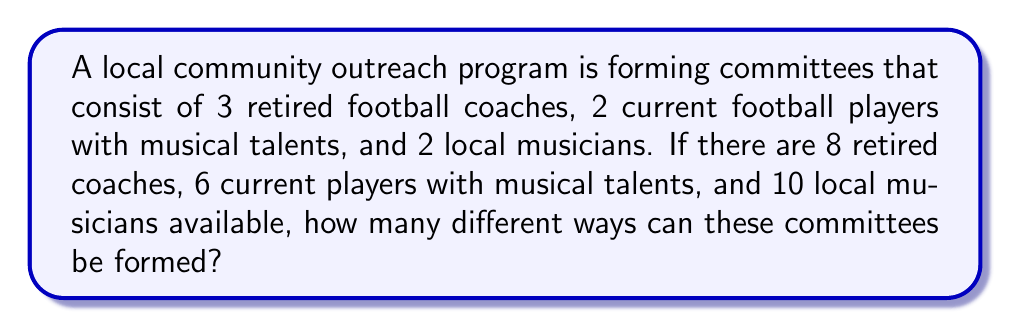Can you answer this question? To solve this problem, we'll use the multiplication principle of counting. We need to select people for each category independently, then multiply the number of ways for each selection.

1. Selecting retired coaches:
   We need to choose 3 out of 8 retired coaches. This is a combination problem.
   Number of ways = $\binom{8}{3} = \frac{8!}{3!(8-3)!} = \frac{8!}{3!5!} = 56$

2. Selecting current players with musical talents:
   We need to choose 2 out of 6 players.
   Number of ways = $\binom{6}{2} = \frac{6!}{2!(6-2)!} = \frac{6!}{2!4!} = 15$

3. Selecting local musicians:
   We need to choose 2 out of 10 musicians.
   Number of ways = $\binom{10}{2} = \frac{10!}{2!(10-2)!} = \frac{10!}{2!8!} = 45$

Now, we apply the multiplication principle. The total number of ways to form the committees is the product of the number of ways to make each individual selection:

Total number of ways = $56 \times 15 \times 45$
Answer: $56 \times 15 \times 45 = 37,800$ ways 